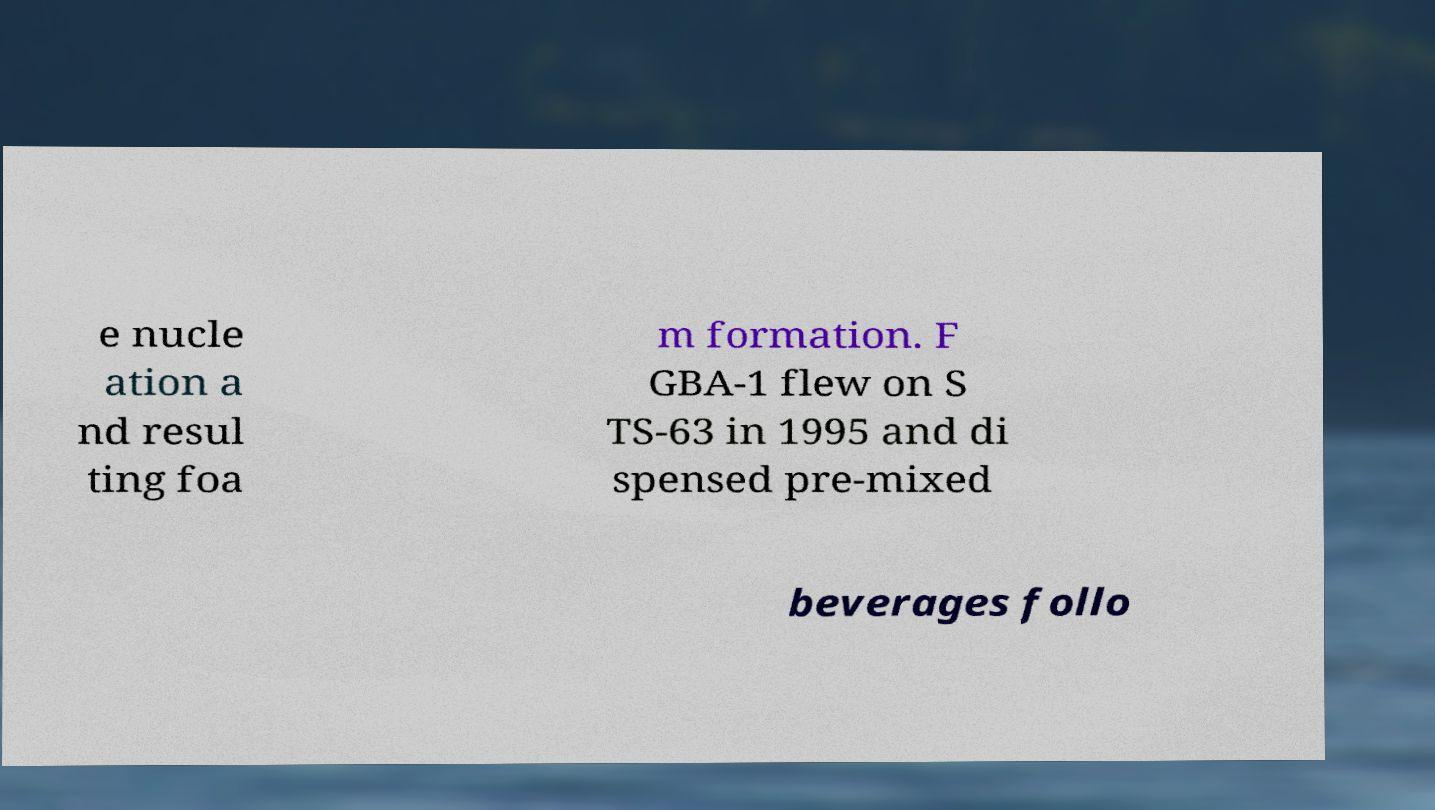Could you extract and type out the text from this image? e nucle ation a nd resul ting foa m formation. F GBA-1 flew on S TS-63 in 1995 and di spensed pre-mixed beverages follo 